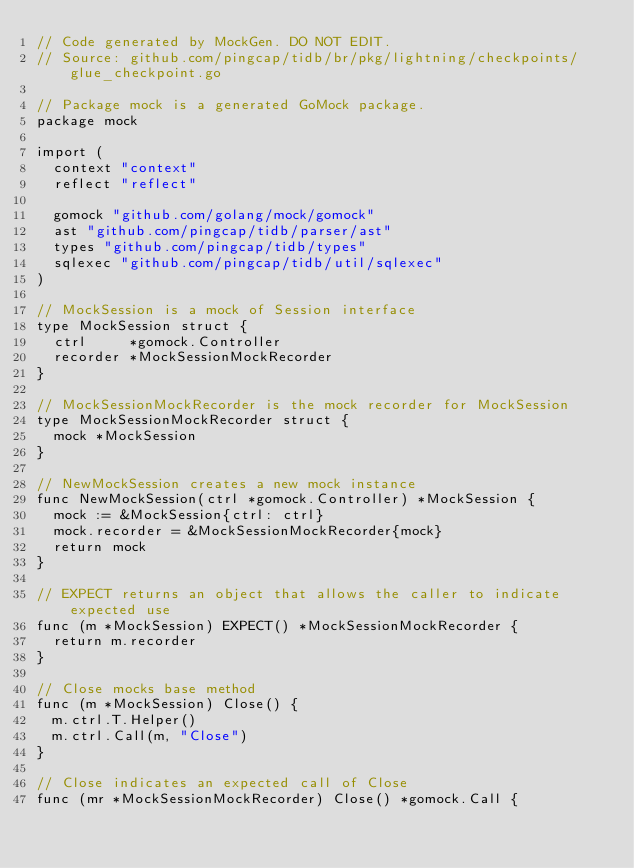Convert code to text. <code><loc_0><loc_0><loc_500><loc_500><_Go_>// Code generated by MockGen. DO NOT EDIT.
// Source: github.com/pingcap/tidb/br/pkg/lightning/checkpoints/glue_checkpoint.go

// Package mock is a generated GoMock package.
package mock

import (
	context "context"
	reflect "reflect"

	gomock "github.com/golang/mock/gomock"
	ast "github.com/pingcap/tidb/parser/ast"
	types "github.com/pingcap/tidb/types"
	sqlexec "github.com/pingcap/tidb/util/sqlexec"
)

// MockSession is a mock of Session interface
type MockSession struct {
	ctrl     *gomock.Controller
	recorder *MockSessionMockRecorder
}

// MockSessionMockRecorder is the mock recorder for MockSession
type MockSessionMockRecorder struct {
	mock *MockSession
}

// NewMockSession creates a new mock instance
func NewMockSession(ctrl *gomock.Controller) *MockSession {
	mock := &MockSession{ctrl: ctrl}
	mock.recorder = &MockSessionMockRecorder{mock}
	return mock
}

// EXPECT returns an object that allows the caller to indicate expected use
func (m *MockSession) EXPECT() *MockSessionMockRecorder {
	return m.recorder
}

// Close mocks base method
func (m *MockSession) Close() {
	m.ctrl.T.Helper()
	m.ctrl.Call(m, "Close")
}

// Close indicates an expected call of Close
func (mr *MockSessionMockRecorder) Close() *gomock.Call {</code> 